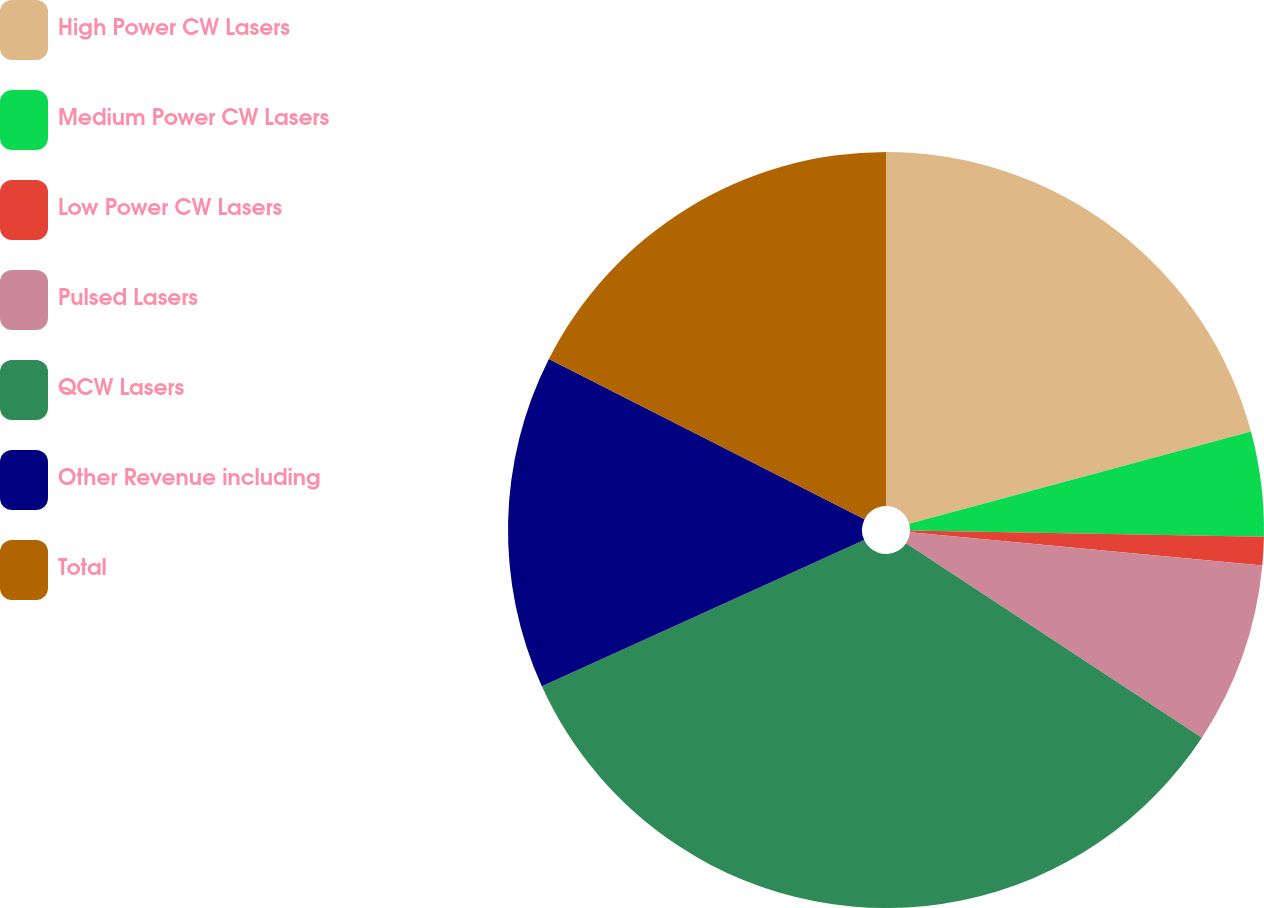Convert chart to OTSL. <chart><loc_0><loc_0><loc_500><loc_500><pie_chart><fcel>High Power CW Lasers<fcel>Medium Power CW Lasers<fcel>Low Power CW Lasers<fcel>Pulsed Lasers<fcel>QCW Lasers<fcel>Other Revenue including<fcel>Total<nl><fcel>20.81%<fcel>4.48%<fcel>1.21%<fcel>7.76%<fcel>33.96%<fcel>14.26%<fcel>17.53%<nl></chart> 